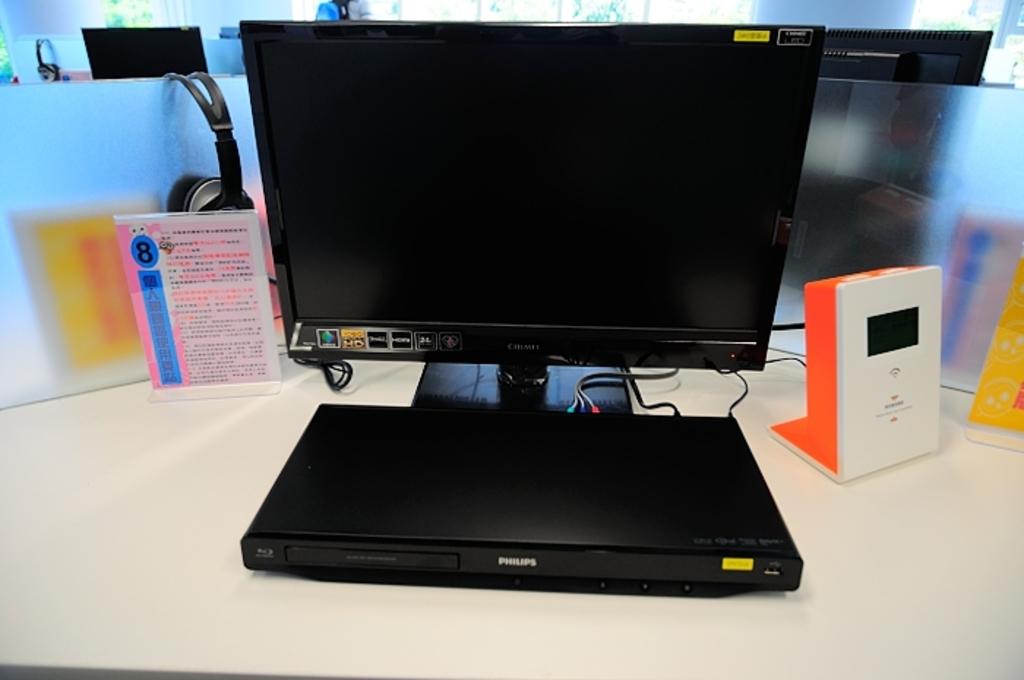What brand of blu-ray player is this?
Offer a very short reply. Philips. What brand is the dvd ?
Offer a terse response. Philips. 